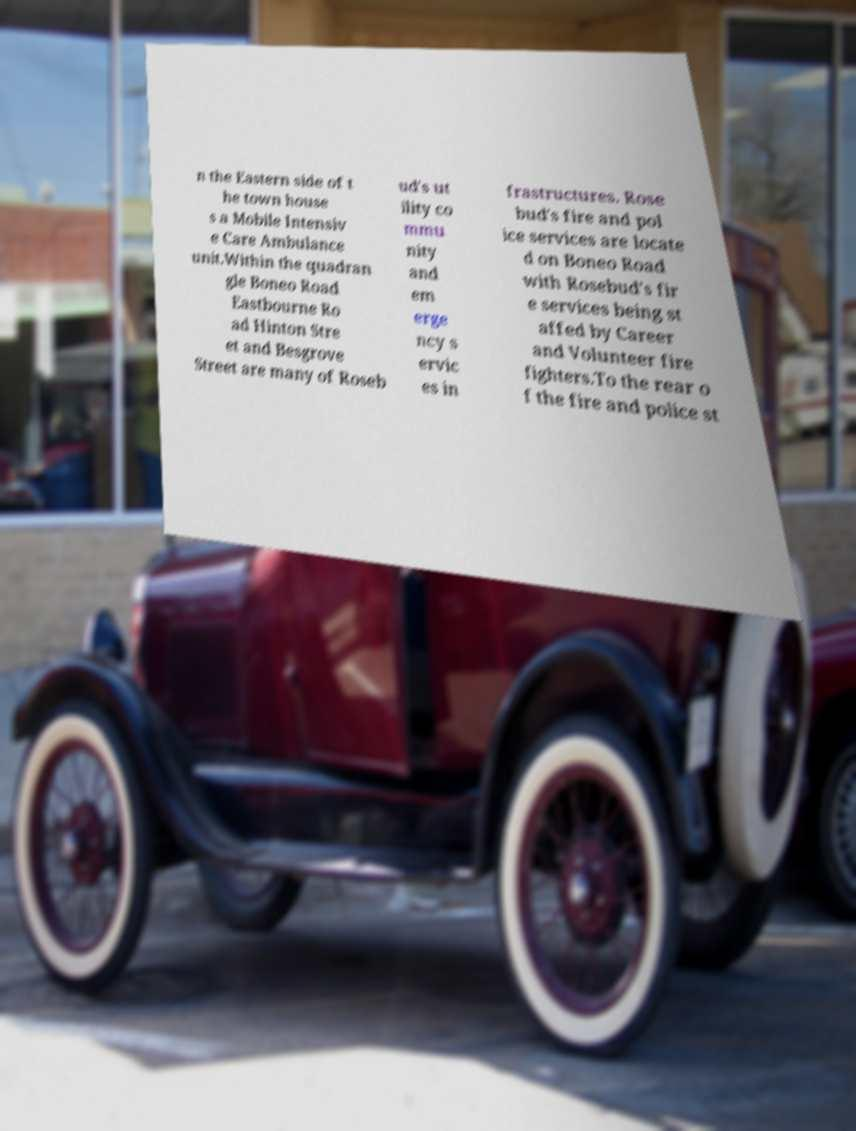Please identify and transcribe the text found in this image. n the Eastern side of t he town house s a Mobile Intensiv e Care Ambulance unit.Within the quadran gle Boneo Road Eastbourne Ro ad Hinton Stre et and Besgrove Street are many of Roseb ud's ut ility co mmu nity and em erge ncy s ervic es in frastructures. Rose bud's fire and pol ice services are locate d on Boneo Road with Rosebud's fir e services being st affed by Career and Volunteer fire fighters.To the rear o f the fire and police st 